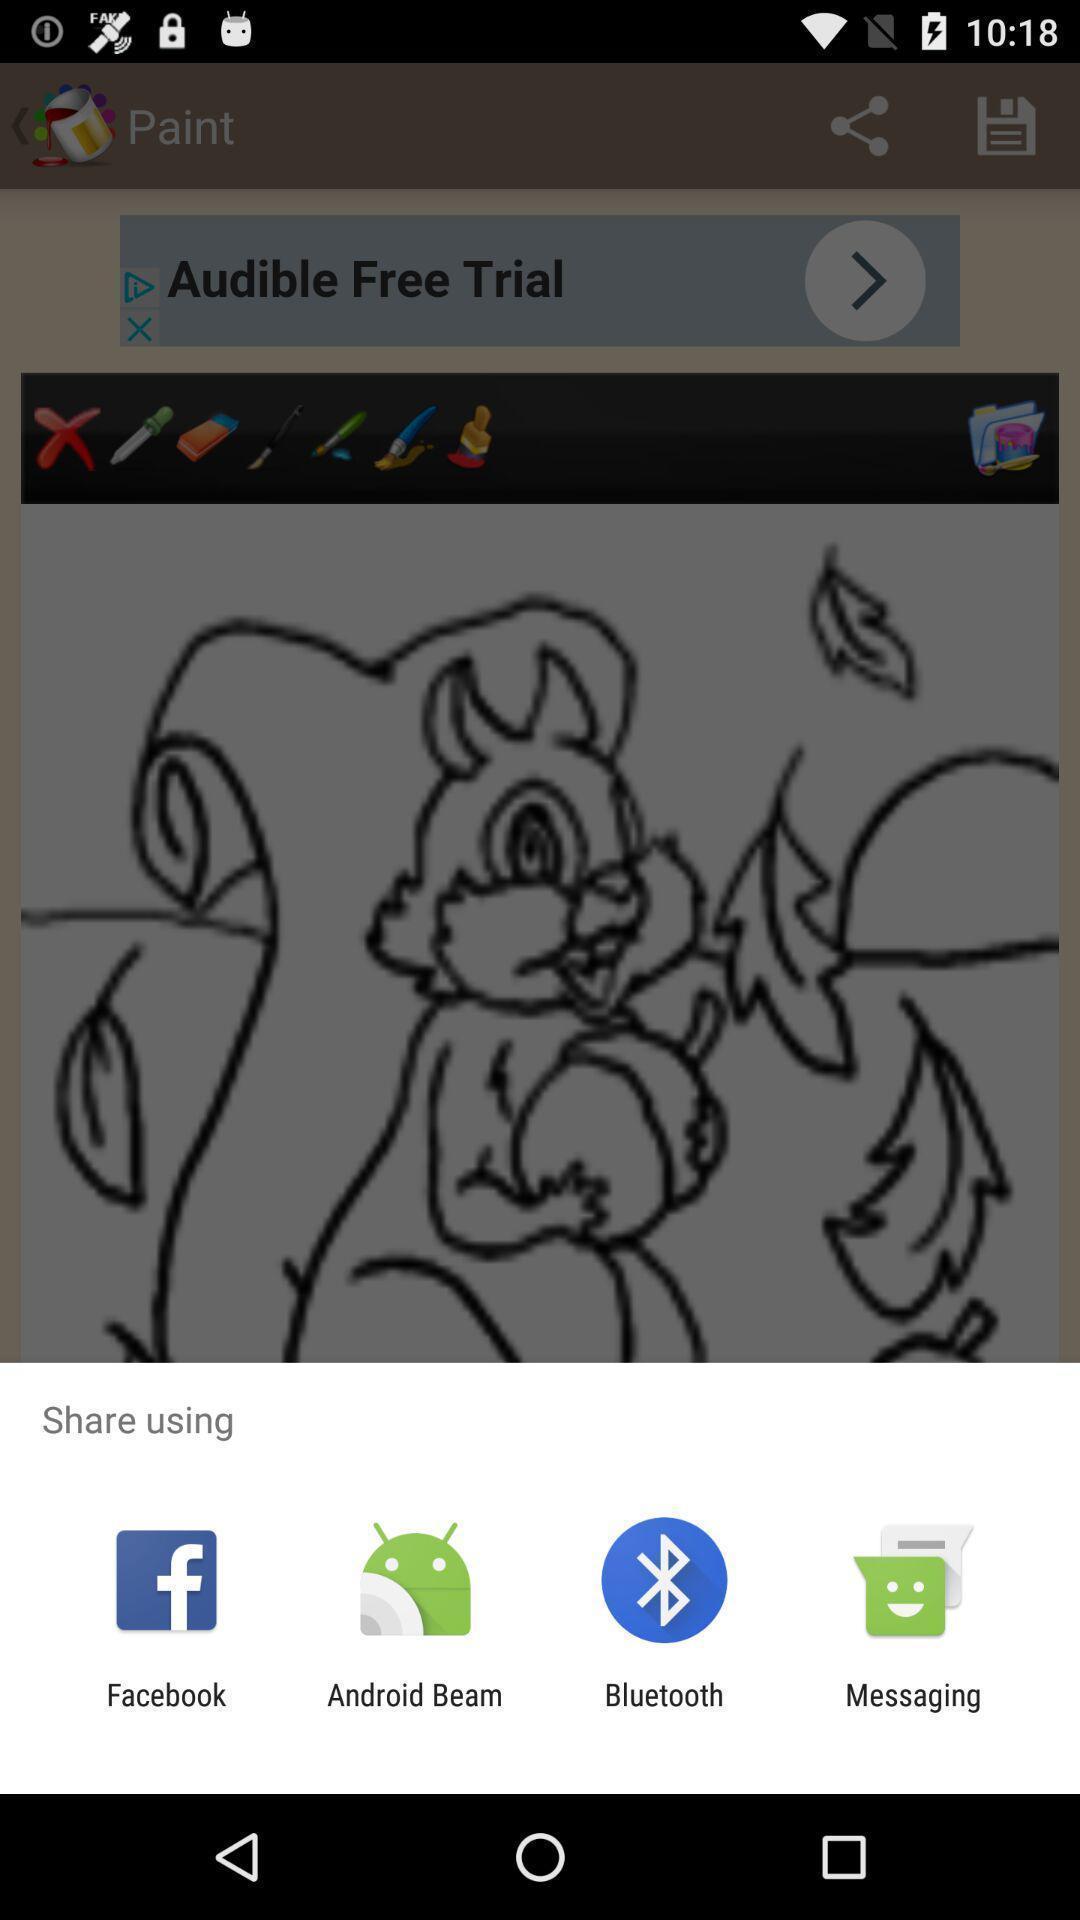Tell me about the visual elements in this screen capture. Share information using different apps. 